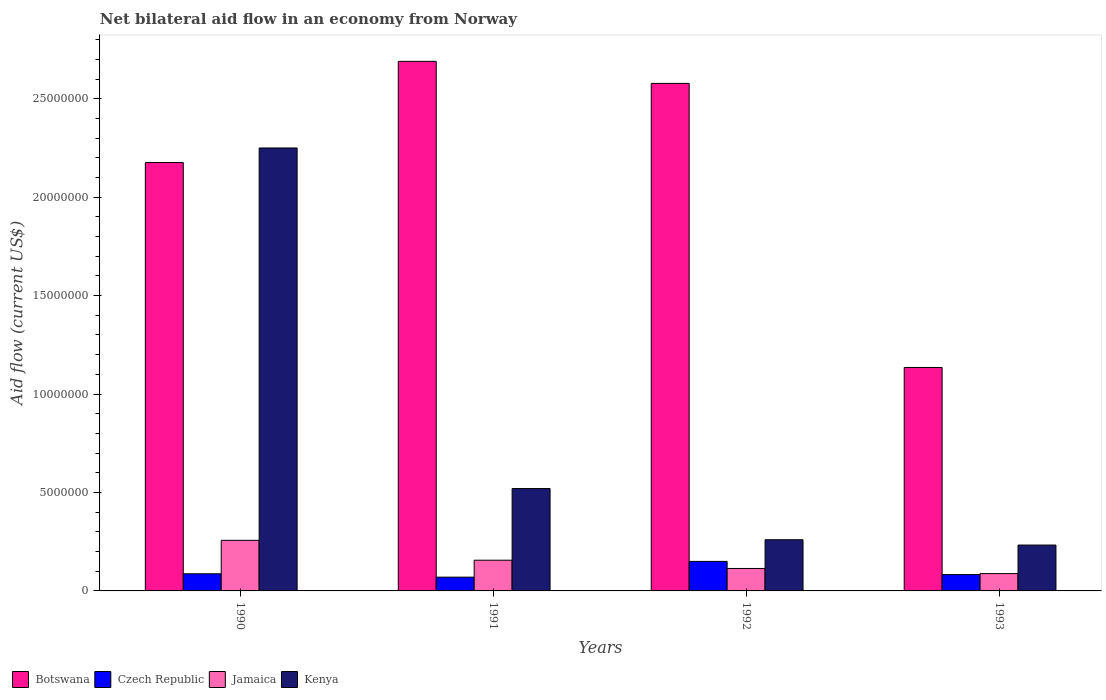How many different coloured bars are there?
Provide a short and direct response. 4. How many groups of bars are there?
Your response must be concise. 4. Are the number of bars per tick equal to the number of legend labels?
Keep it short and to the point. Yes. Are the number of bars on each tick of the X-axis equal?
Ensure brevity in your answer.  Yes. What is the label of the 1st group of bars from the left?
Make the answer very short. 1990. What is the net bilateral aid flow in Botswana in 1991?
Provide a succinct answer. 2.69e+07. Across all years, what is the maximum net bilateral aid flow in Czech Republic?
Your response must be concise. 1.50e+06. Across all years, what is the minimum net bilateral aid flow in Kenya?
Your answer should be very brief. 2.33e+06. In which year was the net bilateral aid flow in Kenya maximum?
Make the answer very short. 1990. What is the total net bilateral aid flow in Kenya in the graph?
Provide a succinct answer. 3.26e+07. What is the difference between the net bilateral aid flow in Botswana in 1991 and that in 1993?
Your answer should be very brief. 1.56e+07. What is the difference between the net bilateral aid flow in Botswana in 1991 and the net bilateral aid flow in Kenya in 1990?
Offer a very short reply. 4.40e+06. What is the average net bilateral aid flow in Jamaica per year?
Your answer should be very brief. 1.54e+06. In the year 1991, what is the difference between the net bilateral aid flow in Botswana and net bilateral aid flow in Kenya?
Provide a succinct answer. 2.17e+07. In how many years, is the net bilateral aid flow in Botswana greater than 9000000 US$?
Your response must be concise. 4. What is the ratio of the net bilateral aid flow in Czech Republic in 1991 to that in 1992?
Offer a terse response. 0.47. Is the difference between the net bilateral aid flow in Botswana in 1990 and 1992 greater than the difference between the net bilateral aid flow in Kenya in 1990 and 1992?
Make the answer very short. No. What is the difference between the highest and the second highest net bilateral aid flow in Botswana?
Give a very brief answer. 1.12e+06. What is the difference between the highest and the lowest net bilateral aid flow in Botswana?
Your answer should be compact. 1.56e+07. What does the 4th bar from the left in 1992 represents?
Provide a succinct answer. Kenya. What does the 1st bar from the right in 1993 represents?
Ensure brevity in your answer.  Kenya. How many bars are there?
Your response must be concise. 16. What is the difference between two consecutive major ticks on the Y-axis?
Your answer should be compact. 5.00e+06. Does the graph contain any zero values?
Provide a succinct answer. No. Does the graph contain grids?
Offer a very short reply. No. Where does the legend appear in the graph?
Provide a succinct answer. Bottom left. What is the title of the graph?
Your answer should be compact. Net bilateral aid flow in an economy from Norway. Does "Euro area" appear as one of the legend labels in the graph?
Keep it short and to the point. No. What is the Aid flow (current US$) of Botswana in 1990?
Give a very brief answer. 2.18e+07. What is the Aid flow (current US$) in Czech Republic in 1990?
Your answer should be compact. 8.70e+05. What is the Aid flow (current US$) of Jamaica in 1990?
Give a very brief answer. 2.57e+06. What is the Aid flow (current US$) in Kenya in 1990?
Give a very brief answer. 2.25e+07. What is the Aid flow (current US$) of Botswana in 1991?
Your answer should be very brief. 2.69e+07. What is the Aid flow (current US$) of Czech Republic in 1991?
Provide a succinct answer. 7.00e+05. What is the Aid flow (current US$) in Jamaica in 1991?
Provide a succinct answer. 1.56e+06. What is the Aid flow (current US$) in Kenya in 1991?
Your response must be concise. 5.20e+06. What is the Aid flow (current US$) in Botswana in 1992?
Keep it short and to the point. 2.58e+07. What is the Aid flow (current US$) of Czech Republic in 1992?
Provide a succinct answer. 1.50e+06. What is the Aid flow (current US$) in Jamaica in 1992?
Make the answer very short. 1.14e+06. What is the Aid flow (current US$) of Kenya in 1992?
Your response must be concise. 2.60e+06. What is the Aid flow (current US$) in Botswana in 1993?
Provide a short and direct response. 1.14e+07. What is the Aid flow (current US$) of Czech Republic in 1993?
Give a very brief answer. 8.30e+05. What is the Aid flow (current US$) in Jamaica in 1993?
Make the answer very short. 8.80e+05. What is the Aid flow (current US$) of Kenya in 1993?
Make the answer very short. 2.33e+06. Across all years, what is the maximum Aid flow (current US$) of Botswana?
Make the answer very short. 2.69e+07. Across all years, what is the maximum Aid flow (current US$) in Czech Republic?
Offer a terse response. 1.50e+06. Across all years, what is the maximum Aid flow (current US$) in Jamaica?
Your response must be concise. 2.57e+06. Across all years, what is the maximum Aid flow (current US$) of Kenya?
Provide a short and direct response. 2.25e+07. Across all years, what is the minimum Aid flow (current US$) in Botswana?
Your answer should be compact. 1.14e+07. Across all years, what is the minimum Aid flow (current US$) in Czech Republic?
Offer a very short reply. 7.00e+05. Across all years, what is the minimum Aid flow (current US$) in Jamaica?
Your answer should be compact. 8.80e+05. Across all years, what is the minimum Aid flow (current US$) in Kenya?
Make the answer very short. 2.33e+06. What is the total Aid flow (current US$) of Botswana in the graph?
Offer a very short reply. 8.58e+07. What is the total Aid flow (current US$) in Czech Republic in the graph?
Your answer should be compact. 3.90e+06. What is the total Aid flow (current US$) in Jamaica in the graph?
Give a very brief answer. 6.15e+06. What is the total Aid flow (current US$) in Kenya in the graph?
Offer a terse response. 3.26e+07. What is the difference between the Aid flow (current US$) of Botswana in 1990 and that in 1991?
Ensure brevity in your answer.  -5.14e+06. What is the difference between the Aid flow (current US$) of Jamaica in 1990 and that in 1991?
Your answer should be compact. 1.01e+06. What is the difference between the Aid flow (current US$) in Kenya in 1990 and that in 1991?
Your answer should be compact. 1.73e+07. What is the difference between the Aid flow (current US$) in Botswana in 1990 and that in 1992?
Make the answer very short. -4.02e+06. What is the difference between the Aid flow (current US$) of Czech Republic in 1990 and that in 1992?
Keep it short and to the point. -6.30e+05. What is the difference between the Aid flow (current US$) of Jamaica in 1990 and that in 1992?
Your answer should be compact. 1.43e+06. What is the difference between the Aid flow (current US$) in Kenya in 1990 and that in 1992?
Keep it short and to the point. 1.99e+07. What is the difference between the Aid flow (current US$) in Botswana in 1990 and that in 1993?
Your response must be concise. 1.04e+07. What is the difference between the Aid flow (current US$) of Jamaica in 1990 and that in 1993?
Ensure brevity in your answer.  1.69e+06. What is the difference between the Aid flow (current US$) of Kenya in 1990 and that in 1993?
Make the answer very short. 2.02e+07. What is the difference between the Aid flow (current US$) in Botswana in 1991 and that in 1992?
Provide a short and direct response. 1.12e+06. What is the difference between the Aid flow (current US$) in Czech Republic in 1991 and that in 1992?
Offer a terse response. -8.00e+05. What is the difference between the Aid flow (current US$) in Kenya in 1991 and that in 1992?
Your response must be concise. 2.60e+06. What is the difference between the Aid flow (current US$) in Botswana in 1991 and that in 1993?
Make the answer very short. 1.56e+07. What is the difference between the Aid flow (current US$) of Jamaica in 1991 and that in 1993?
Offer a terse response. 6.80e+05. What is the difference between the Aid flow (current US$) in Kenya in 1991 and that in 1993?
Offer a very short reply. 2.87e+06. What is the difference between the Aid flow (current US$) in Botswana in 1992 and that in 1993?
Provide a succinct answer. 1.44e+07. What is the difference between the Aid flow (current US$) of Czech Republic in 1992 and that in 1993?
Your answer should be compact. 6.70e+05. What is the difference between the Aid flow (current US$) in Botswana in 1990 and the Aid flow (current US$) in Czech Republic in 1991?
Ensure brevity in your answer.  2.11e+07. What is the difference between the Aid flow (current US$) of Botswana in 1990 and the Aid flow (current US$) of Jamaica in 1991?
Provide a short and direct response. 2.02e+07. What is the difference between the Aid flow (current US$) in Botswana in 1990 and the Aid flow (current US$) in Kenya in 1991?
Provide a succinct answer. 1.66e+07. What is the difference between the Aid flow (current US$) of Czech Republic in 1990 and the Aid flow (current US$) of Jamaica in 1991?
Your response must be concise. -6.90e+05. What is the difference between the Aid flow (current US$) of Czech Republic in 1990 and the Aid flow (current US$) of Kenya in 1991?
Your answer should be very brief. -4.33e+06. What is the difference between the Aid flow (current US$) in Jamaica in 1990 and the Aid flow (current US$) in Kenya in 1991?
Ensure brevity in your answer.  -2.63e+06. What is the difference between the Aid flow (current US$) of Botswana in 1990 and the Aid flow (current US$) of Czech Republic in 1992?
Your answer should be very brief. 2.03e+07. What is the difference between the Aid flow (current US$) of Botswana in 1990 and the Aid flow (current US$) of Jamaica in 1992?
Offer a terse response. 2.06e+07. What is the difference between the Aid flow (current US$) of Botswana in 1990 and the Aid flow (current US$) of Kenya in 1992?
Provide a succinct answer. 1.92e+07. What is the difference between the Aid flow (current US$) in Czech Republic in 1990 and the Aid flow (current US$) in Jamaica in 1992?
Give a very brief answer. -2.70e+05. What is the difference between the Aid flow (current US$) in Czech Republic in 1990 and the Aid flow (current US$) in Kenya in 1992?
Provide a succinct answer. -1.73e+06. What is the difference between the Aid flow (current US$) in Jamaica in 1990 and the Aid flow (current US$) in Kenya in 1992?
Give a very brief answer. -3.00e+04. What is the difference between the Aid flow (current US$) in Botswana in 1990 and the Aid flow (current US$) in Czech Republic in 1993?
Give a very brief answer. 2.09e+07. What is the difference between the Aid flow (current US$) of Botswana in 1990 and the Aid flow (current US$) of Jamaica in 1993?
Your answer should be compact. 2.09e+07. What is the difference between the Aid flow (current US$) of Botswana in 1990 and the Aid flow (current US$) of Kenya in 1993?
Your response must be concise. 1.94e+07. What is the difference between the Aid flow (current US$) in Czech Republic in 1990 and the Aid flow (current US$) in Jamaica in 1993?
Give a very brief answer. -10000. What is the difference between the Aid flow (current US$) of Czech Republic in 1990 and the Aid flow (current US$) of Kenya in 1993?
Offer a terse response. -1.46e+06. What is the difference between the Aid flow (current US$) in Jamaica in 1990 and the Aid flow (current US$) in Kenya in 1993?
Your answer should be very brief. 2.40e+05. What is the difference between the Aid flow (current US$) of Botswana in 1991 and the Aid flow (current US$) of Czech Republic in 1992?
Ensure brevity in your answer.  2.54e+07. What is the difference between the Aid flow (current US$) in Botswana in 1991 and the Aid flow (current US$) in Jamaica in 1992?
Your answer should be compact. 2.58e+07. What is the difference between the Aid flow (current US$) in Botswana in 1991 and the Aid flow (current US$) in Kenya in 1992?
Ensure brevity in your answer.  2.43e+07. What is the difference between the Aid flow (current US$) in Czech Republic in 1991 and the Aid flow (current US$) in Jamaica in 1992?
Give a very brief answer. -4.40e+05. What is the difference between the Aid flow (current US$) of Czech Republic in 1991 and the Aid flow (current US$) of Kenya in 1992?
Your answer should be compact. -1.90e+06. What is the difference between the Aid flow (current US$) of Jamaica in 1991 and the Aid flow (current US$) of Kenya in 1992?
Make the answer very short. -1.04e+06. What is the difference between the Aid flow (current US$) of Botswana in 1991 and the Aid flow (current US$) of Czech Republic in 1993?
Ensure brevity in your answer.  2.61e+07. What is the difference between the Aid flow (current US$) of Botswana in 1991 and the Aid flow (current US$) of Jamaica in 1993?
Make the answer very short. 2.60e+07. What is the difference between the Aid flow (current US$) in Botswana in 1991 and the Aid flow (current US$) in Kenya in 1993?
Offer a very short reply. 2.46e+07. What is the difference between the Aid flow (current US$) of Czech Republic in 1991 and the Aid flow (current US$) of Jamaica in 1993?
Ensure brevity in your answer.  -1.80e+05. What is the difference between the Aid flow (current US$) in Czech Republic in 1991 and the Aid flow (current US$) in Kenya in 1993?
Make the answer very short. -1.63e+06. What is the difference between the Aid flow (current US$) of Jamaica in 1991 and the Aid flow (current US$) of Kenya in 1993?
Offer a very short reply. -7.70e+05. What is the difference between the Aid flow (current US$) in Botswana in 1992 and the Aid flow (current US$) in Czech Republic in 1993?
Make the answer very short. 2.50e+07. What is the difference between the Aid flow (current US$) of Botswana in 1992 and the Aid flow (current US$) of Jamaica in 1993?
Offer a terse response. 2.49e+07. What is the difference between the Aid flow (current US$) in Botswana in 1992 and the Aid flow (current US$) in Kenya in 1993?
Offer a terse response. 2.34e+07. What is the difference between the Aid flow (current US$) of Czech Republic in 1992 and the Aid flow (current US$) of Jamaica in 1993?
Your answer should be very brief. 6.20e+05. What is the difference between the Aid flow (current US$) in Czech Republic in 1992 and the Aid flow (current US$) in Kenya in 1993?
Your answer should be compact. -8.30e+05. What is the difference between the Aid flow (current US$) in Jamaica in 1992 and the Aid flow (current US$) in Kenya in 1993?
Your answer should be compact. -1.19e+06. What is the average Aid flow (current US$) in Botswana per year?
Make the answer very short. 2.14e+07. What is the average Aid flow (current US$) of Czech Republic per year?
Your response must be concise. 9.75e+05. What is the average Aid flow (current US$) of Jamaica per year?
Ensure brevity in your answer.  1.54e+06. What is the average Aid flow (current US$) in Kenya per year?
Your answer should be very brief. 8.16e+06. In the year 1990, what is the difference between the Aid flow (current US$) in Botswana and Aid flow (current US$) in Czech Republic?
Offer a terse response. 2.09e+07. In the year 1990, what is the difference between the Aid flow (current US$) in Botswana and Aid flow (current US$) in Jamaica?
Provide a short and direct response. 1.92e+07. In the year 1990, what is the difference between the Aid flow (current US$) in Botswana and Aid flow (current US$) in Kenya?
Keep it short and to the point. -7.40e+05. In the year 1990, what is the difference between the Aid flow (current US$) of Czech Republic and Aid flow (current US$) of Jamaica?
Your answer should be compact. -1.70e+06. In the year 1990, what is the difference between the Aid flow (current US$) in Czech Republic and Aid flow (current US$) in Kenya?
Make the answer very short. -2.16e+07. In the year 1990, what is the difference between the Aid flow (current US$) of Jamaica and Aid flow (current US$) of Kenya?
Make the answer very short. -1.99e+07. In the year 1991, what is the difference between the Aid flow (current US$) in Botswana and Aid flow (current US$) in Czech Republic?
Make the answer very short. 2.62e+07. In the year 1991, what is the difference between the Aid flow (current US$) in Botswana and Aid flow (current US$) in Jamaica?
Keep it short and to the point. 2.53e+07. In the year 1991, what is the difference between the Aid flow (current US$) of Botswana and Aid flow (current US$) of Kenya?
Offer a very short reply. 2.17e+07. In the year 1991, what is the difference between the Aid flow (current US$) in Czech Republic and Aid flow (current US$) in Jamaica?
Provide a short and direct response. -8.60e+05. In the year 1991, what is the difference between the Aid flow (current US$) in Czech Republic and Aid flow (current US$) in Kenya?
Provide a short and direct response. -4.50e+06. In the year 1991, what is the difference between the Aid flow (current US$) in Jamaica and Aid flow (current US$) in Kenya?
Offer a very short reply. -3.64e+06. In the year 1992, what is the difference between the Aid flow (current US$) of Botswana and Aid flow (current US$) of Czech Republic?
Keep it short and to the point. 2.43e+07. In the year 1992, what is the difference between the Aid flow (current US$) of Botswana and Aid flow (current US$) of Jamaica?
Your answer should be very brief. 2.46e+07. In the year 1992, what is the difference between the Aid flow (current US$) in Botswana and Aid flow (current US$) in Kenya?
Your answer should be compact. 2.32e+07. In the year 1992, what is the difference between the Aid flow (current US$) of Czech Republic and Aid flow (current US$) of Kenya?
Keep it short and to the point. -1.10e+06. In the year 1992, what is the difference between the Aid flow (current US$) in Jamaica and Aid flow (current US$) in Kenya?
Give a very brief answer. -1.46e+06. In the year 1993, what is the difference between the Aid flow (current US$) in Botswana and Aid flow (current US$) in Czech Republic?
Your answer should be compact. 1.05e+07. In the year 1993, what is the difference between the Aid flow (current US$) of Botswana and Aid flow (current US$) of Jamaica?
Ensure brevity in your answer.  1.05e+07. In the year 1993, what is the difference between the Aid flow (current US$) of Botswana and Aid flow (current US$) of Kenya?
Offer a terse response. 9.02e+06. In the year 1993, what is the difference between the Aid flow (current US$) in Czech Republic and Aid flow (current US$) in Jamaica?
Offer a very short reply. -5.00e+04. In the year 1993, what is the difference between the Aid flow (current US$) of Czech Republic and Aid flow (current US$) of Kenya?
Provide a succinct answer. -1.50e+06. In the year 1993, what is the difference between the Aid flow (current US$) of Jamaica and Aid flow (current US$) of Kenya?
Keep it short and to the point. -1.45e+06. What is the ratio of the Aid flow (current US$) in Botswana in 1990 to that in 1991?
Your answer should be compact. 0.81. What is the ratio of the Aid flow (current US$) in Czech Republic in 1990 to that in 1991?
Provide a succinct answer. 1.24. What is the ratio of the Aid flow (current US$) of Jamaica in 1990 to that in 1991?
Make the answer very short. 1.65. What is the ratio of the Aid flow (current US$) in Kenya in 1990 to that in 1991?
Provide a short and direct response. 4.33. What is the ratio of the Aid flow (current US$) in Botswana in 1990 to that in 1992?
Keep it short and to the point. 0.84. What is the ratio of the Aid flow (current US$) in Czech Republic in 1990 to that in 1992?
Offer a very short reply. 0.58. What is the ratio of the Aid flow (current US$) of Jamaica in 1990 to that in 1992?
Make the answer very short. 2.25. What is the ratio of the Aid flow (current US$) in Kenya in 1990 to that in 1992?
Make the answer very short. 8.65. What is the ratio of the Aid flow (current US$) in Botswana in 1990 to that in 1993?
Keep it short and to the point. 1.92. What is the ratio of the Aid flow (current US$) of Czech Republic in 1990 to that in 1993?
Give a very brief answer. 1.05. What is the ratio of the Aid flow (current US$) in Jamaica in 1990 to that in 1993?
Provide a succinct answer. 2.92. What is the ratio of the Aid flow (current US$) of Kenya in 1990 to that in 1993?
Ensure brevity in your answer.  9.66. What is the ratio of the Aid flow (current US$) of Botswana in 1991 to that in 1992?
Keep it short and to the point. 1.04. What is the ratio of the Aid flow (current US$) of Czech Republic in 1991 to that in 1992?
Your answer should be very brief. 0.47. What is the ratio of the Aid flow (current US$) of Jamaica in 1991 to that in 1992?
Provide a succinct answer. 1.37. What is the ratio of the Aid flow (current US$) in Kenya in 1991 to that in 1992?
Give a very brief answer. 2. What is the ratio of the Aid flow (current US$) in Botswana in 1991 to that in 1993?
Offer a very short reply. 2.37. What is the ratio of the Aid flow (current US$) of Czech Republic in 1991 to that in 1993?
Give a very brief answer. 0.84. What is the ratio of the Aid flow (current US$) of Jamaica in 1991 to that in 1993?
Make the answer very short. 1.77. What is the ratio of the Aid flow (current US$) of Kenya in 1991 to that in 1993?
Offer a very short reply. 2.23. What is the ratio of the Aid flow (current US$) of Botswana in 1992 to that in 1993?
Provide a short and direct response. 2.27. What is the ratio of the Aid flow (current US$) in Czech Republic in 1992 to that in 1993?
Make the answer very short. 1.81. What is the ratio of the Aid flow (current US$) of Jamaica in 1992 to that in 1993?
Give a very brief answer. 1.3. What is the ratio of the Aid flow (current US$) of Kenya in 1992 to that in 1993?
Keep it short and to the point. 1.12. What is the difference between the highest and the second highest Aid flow (current US$) in Botswana?
Offer a terse response. 1.12e+06. What is the difference between the highest and the second highest Aid flow (current US$) in Czech Republic?
Your answer should be very brief. 6.30e+05. What is the difference between the highest and the second highest Aid flow (current US$) of Jamaica?
Give a very brief answer. 1.01e+06. What is the difference between the highest and the second highest Aid flow (current US$) in Kenya?
Your answer should be very brief. 1.73e+07. What is the difference between the highest and the lowest Aid flow (current US$) in Botswana?
Offer a very short reply. 1.56e+07. What is the difference between the highest and the lowest Aid flow (current US$) of Jamaica?
Offer a terse response. 1.69e+06. What is the difference between the highest and the lowest Aid flow (current US$) in Kenya?
Give a very brief answer. 2.02e+07. 